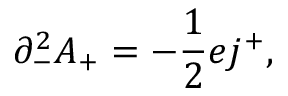<formula> <loc_0><loc_0><loc_500><loc_500>{ \partial } _ { - } ^ { 2 } A _ { + } = - \frac { 1 } { 2 } e j ^ { + } ,</formula> 